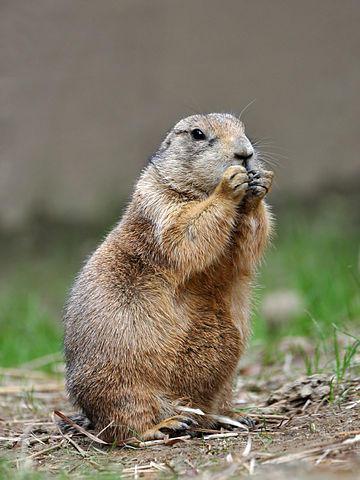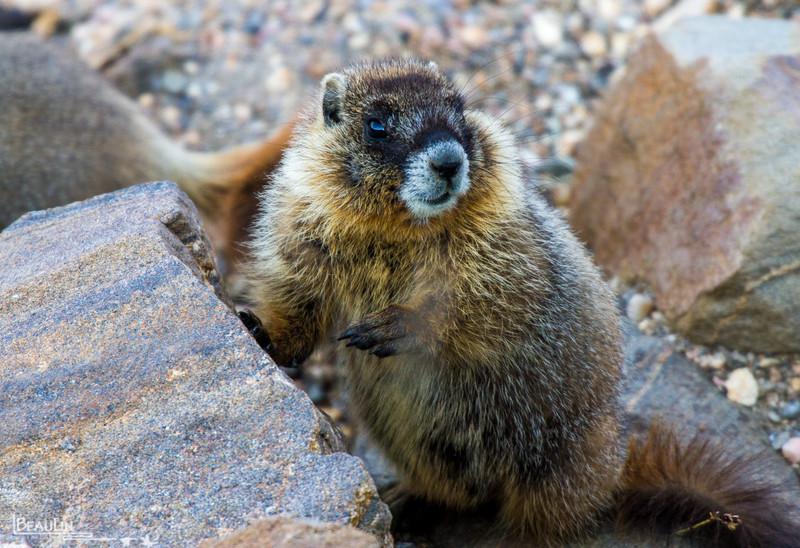The first image is the image on the left, the second image is the image on the right. For the images shown, is this caption "The animals in both images face approximately the same direction." true? Answer yes or no. Yes. 